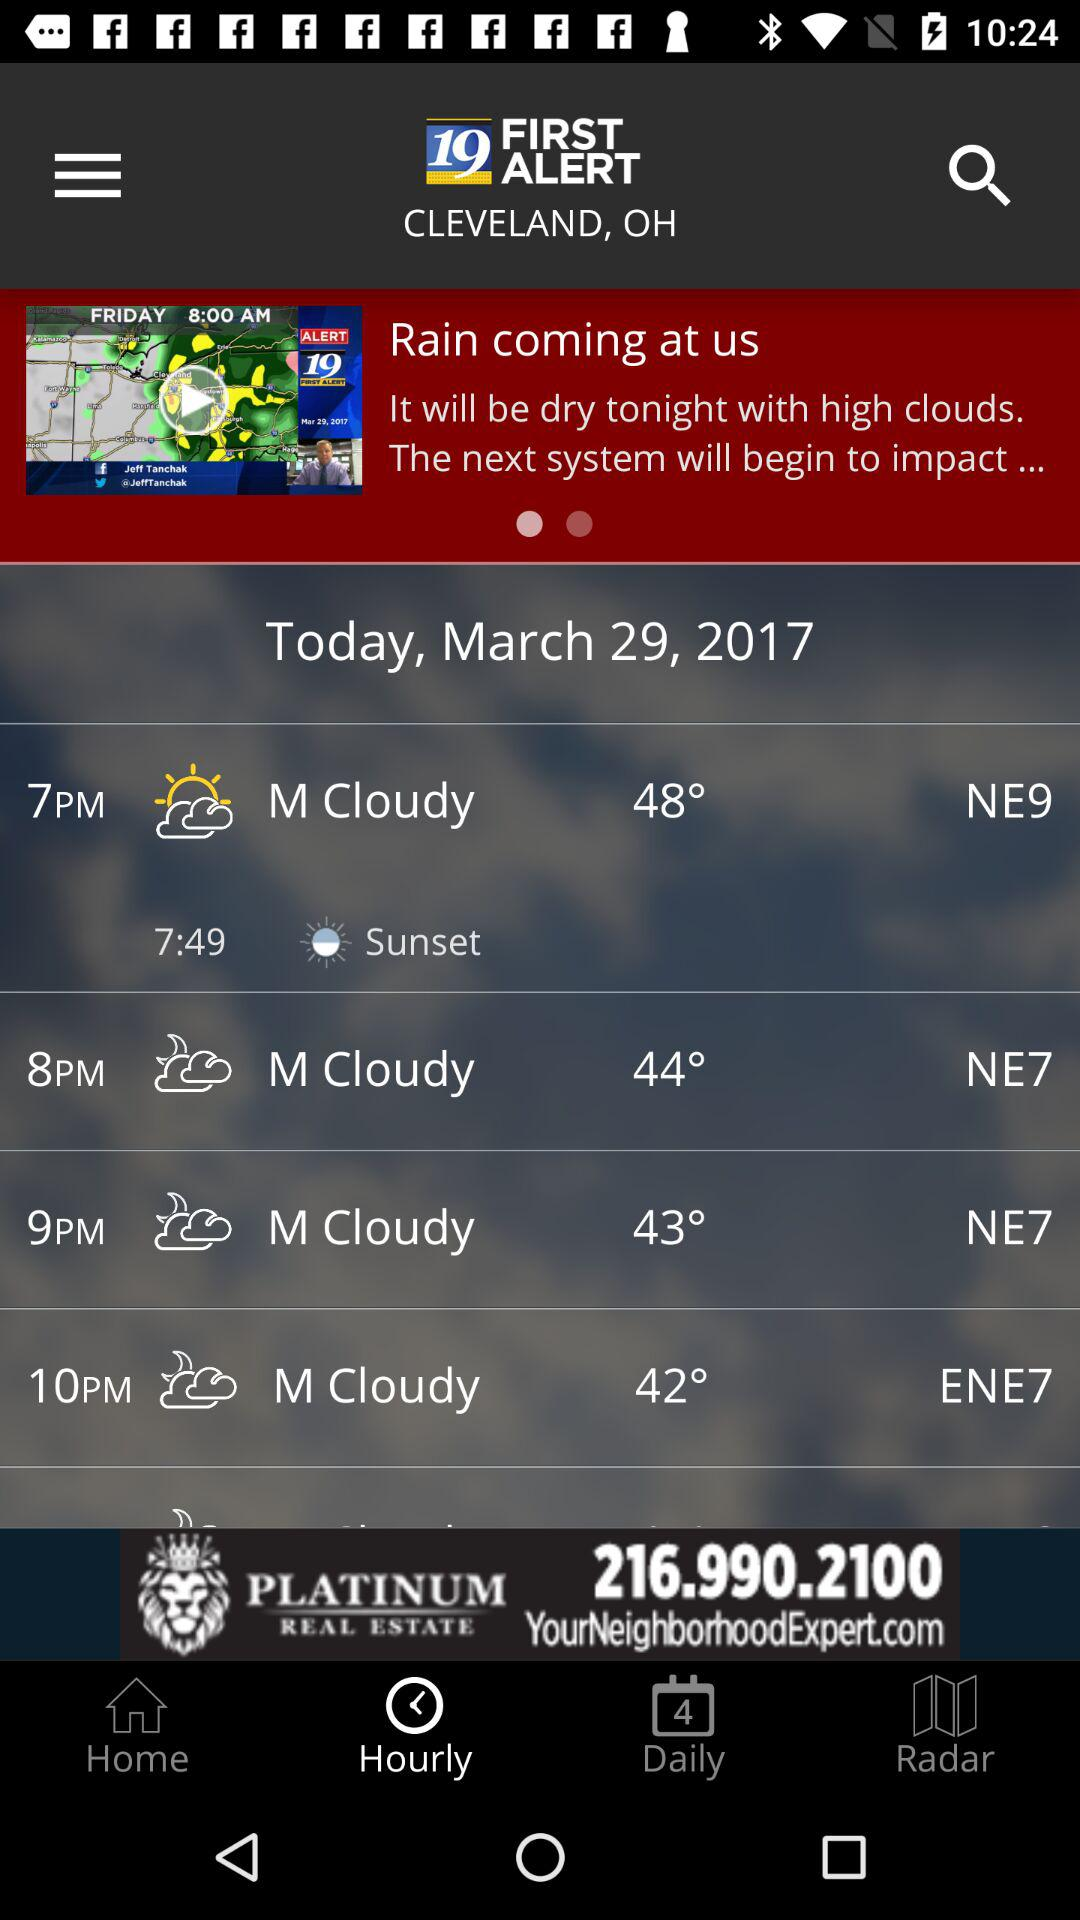What is the difference in degrees between the temperature at 7pm and 10pm?
Answer the question using a single word or phrase. 6 